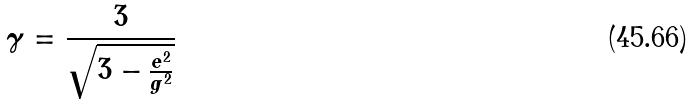Convert formula to latex. <formula><loc_0><loc_0><loc_500><loc_500>\gamma = \frac { 3 } { \sqrt { 3 - \frac { e ^ { 2 } } { g ^ { 2 } } } }</formula> 